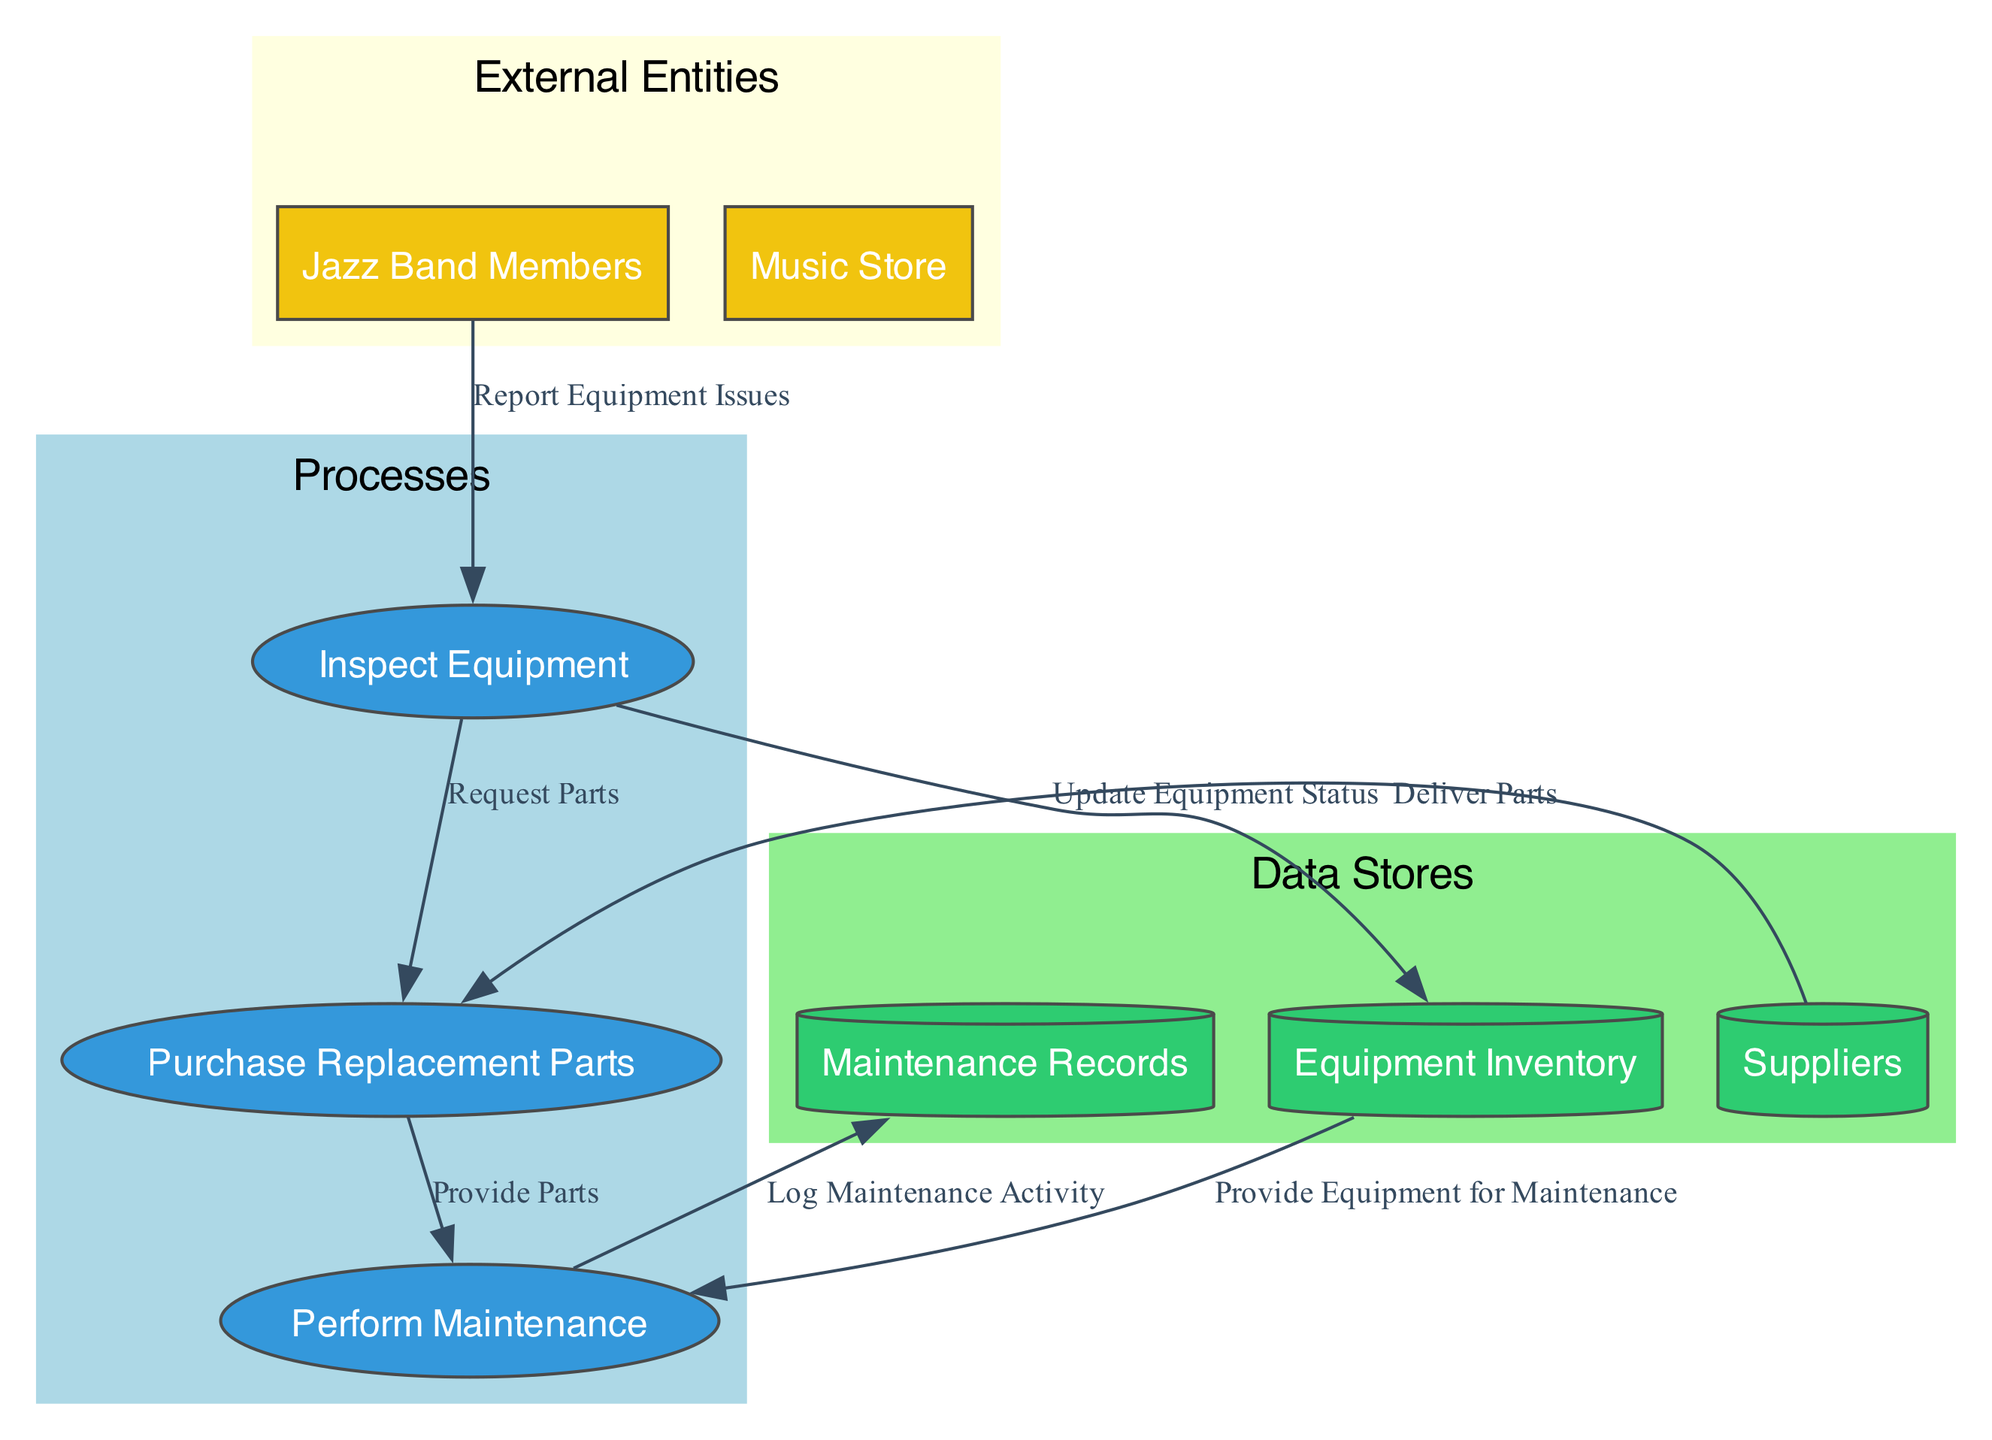What's the first process in the workflow? The first process listed in the diagram is "Inspect Equipment," which is identified as process ID 1.
Answer: Inspect Equipment How many external entities are present in the diagram? The diagram contains two external entities: "Jazz Band Members" and "Music Store," which can be counted from the list of external entities.
Answer: 2 What is the purpose of the "Maintenance Records" data store? The "Maintenance Records" data store logs past maintenance activities and outcomes, as described in its details.
Answer: Logs of past maintenance activities and outcomes What information do Jazz Band Members provide to the inspection process? Jazz Band Members report issues related to the equipment, which is demonstrated by the "Report Equipment Issues" data flow from them to the "Inspect Equipment" process.
Answer: Report Equipment Issues Which data store is updated after equipment inspection? After equipment inspection, the "Equipment Inventory" data store is updated with the details about the condition of inspected equipment, as noted in the "Update Equipment Status" flow.
Answer: Equipment Inventory What part do suppliers play in the replacement parts process? Suppliers deliver the ordered replacement parts to the "Purchase Replacement Parts" process, shown in the "Deliver Parts" data flow.
Answer: Deliver Parts How many total processes are in the workflow? The workflow contains three processes: Inspect Equipment, Purchase Replacement Parts, and Perform Maintenance, which are listed in the process section.
Answer: 3 What flow connects the "Perform Maintenance" process to the "Maintenance Records"? The flow named "Log Maintenance Activity" connects the "Perform Maintenance" process to the "Maintenance Records," capturing the details of maintenance performed.
Answer: Log Maintenance Activity What is the relationship between "Purchase Replacement Parts" and "Perform Maintenance"? The "Purchase Replacement Parts" process provides necessary parts for maintenance, as indicated by the "Provide Parts" data flow to the "Perform Maintenance" process.
Answer: Provide Parts 